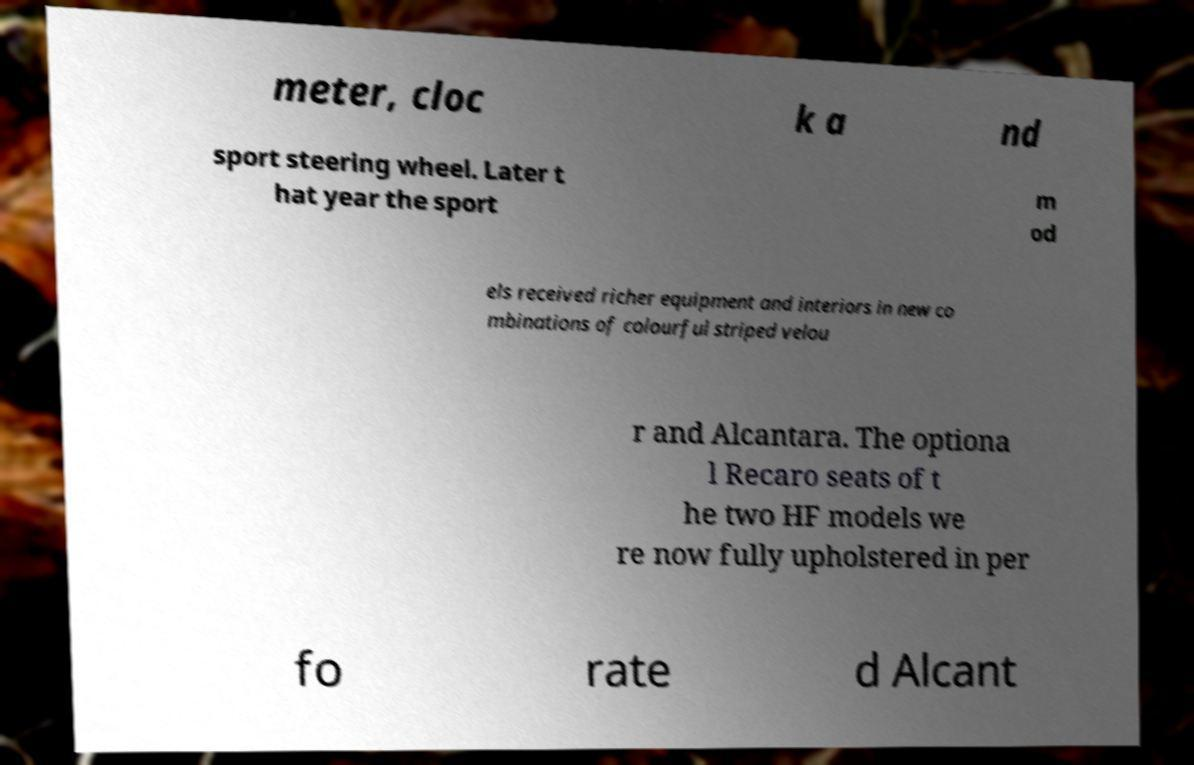There's text embedded in this image that I need extracted. Can you transcribe it verbatim? meter, cloc k a nd sport steering wheel. Later t hat year the sport m od els received richer equipment and interiors in new co mbinations of colourful striped velou r and Alcantara. The optiona l Recaro seats of t he two HF models we re now fully upholstered in per fo rate d Alcant 